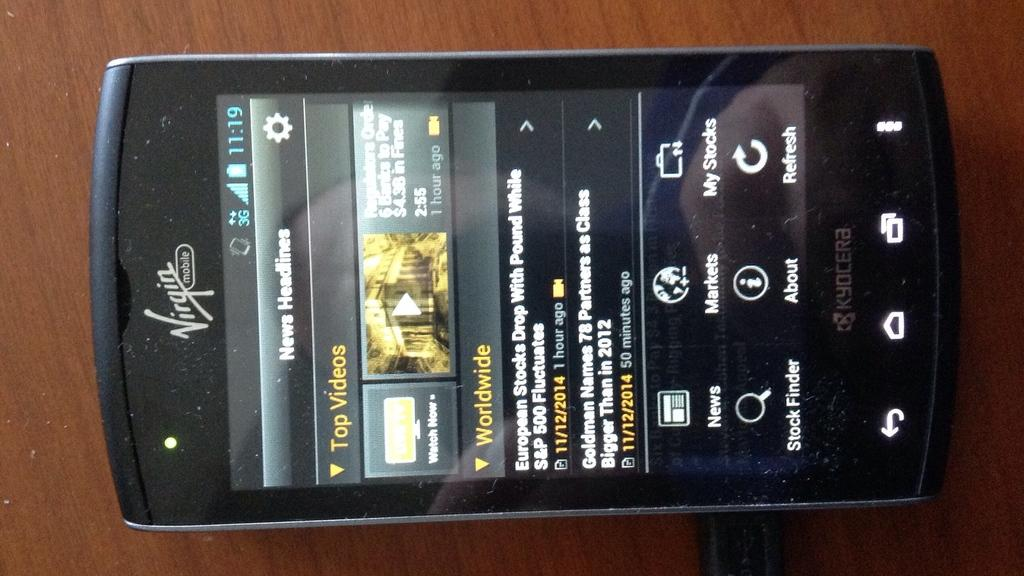<image>
Share a concise interpretation of the image provided. A Virgin Mobile phone displays news headlines and top videos. 